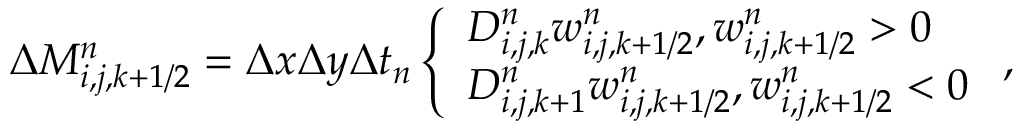<formula> <loc_0><loc_0><loc_500><loc_500>\begin{array} { r } { \Delta M _ { i , j , k + 1 / 2 } ^ { n } = \Delta x \Delta y \Delta t _ { n } \left \{ \begin{array} { l l } { D _ { i , j , k } ^ { n } w _ { i , j , k + 1 / 2 } ^ { n } , w _ { i , j , k + 1 / 2 } ^ { n } > 0 } \\ { D _ { i , j , k + 1 } ^ { n } w _ { i , j , k + 1 / 2 } ^ { n } , w _ { i , j , k + 1 / 2 } ^ { n } < 0 } \end{array} , } \end{array}</formula> 